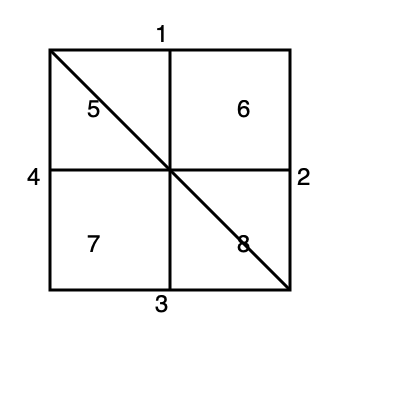Based on the numbered sequence diagram provided, which of the following represents the correct stroke order for the Chinese character 田 (tián, meaning "field")?

A) 1, 2, 3, 4, 5, 6, 7, 8
B) 1, 3, 2, 4, 5, 6, 7, 8
C) 1, 2, 4, 3, 5, 6, 7, 8
D) 1, 3, 4, 2, 5, 6, 7, 8 To determine the correct stroke order for the Chinese character 田 (tián), we need to follow the standard rules of Chinese character stroke order:

1. Top to bottom: The topmost horizontal stroke (1) is written first.
2. Left to right: The right vertical stroke (2) is written before the bottom horizontal stroke (3).
3. Outside to inside: The left vertical stroke (4) is written last among the outer strokes.
4. Enclosing strokes before inner strokes: The four outer strokes (1, 2, 3, 4) are written before the inner strokes.
5. Center vertical before center horizontal: The center vertical stroke (5, 6) is written before the center horizontal stroke (7, 8).
6. Left-falling diagonal stroke before right-falling diagonal stroke: This rule doesn't apply to this character.

Following these rules, the correct stroke order for 田 is:

1. Top horizontal stroke
2. Right vertical stroke
3. Bottom horizontal stroke
4. Left vertical stroke
5. Upper half of center vertical stroke
6. Lower half of center vertical stroke
7. Left half of center horizontal stroke
8. Right half of center horizontal stroke

This sequence corresponds to option A: 1, 2, 3, 4, 5, 6, 7, 8.
Answer: A 